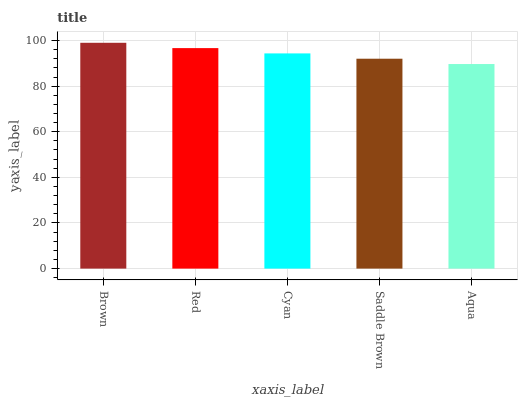Is Aqua the minimum?
Answer yes or no. Yes. Is Brown the maximum?
Answer yes or no. Yes. Is Red the minimum?
Answer yes or no. No. Is Red the maximum?
Answer yes or no. No. Is Brown greater than Red?
Answer yes or no. Yes. Is Red less than Brown?
Answer yes or no. Yes. Is Red greater than Brown?
Answer yes or no. No. Is Brown less than Red?
Answer yes or no. No. Is Cyan the high median?
Answer yes or no. Yes. Is Cyan the low median?
Answer yes or no. Yes. Is Saddle Brown the high median?
Answer yes or no. No. Is Saddle Brown the low median?
Answer yes or no. No. 